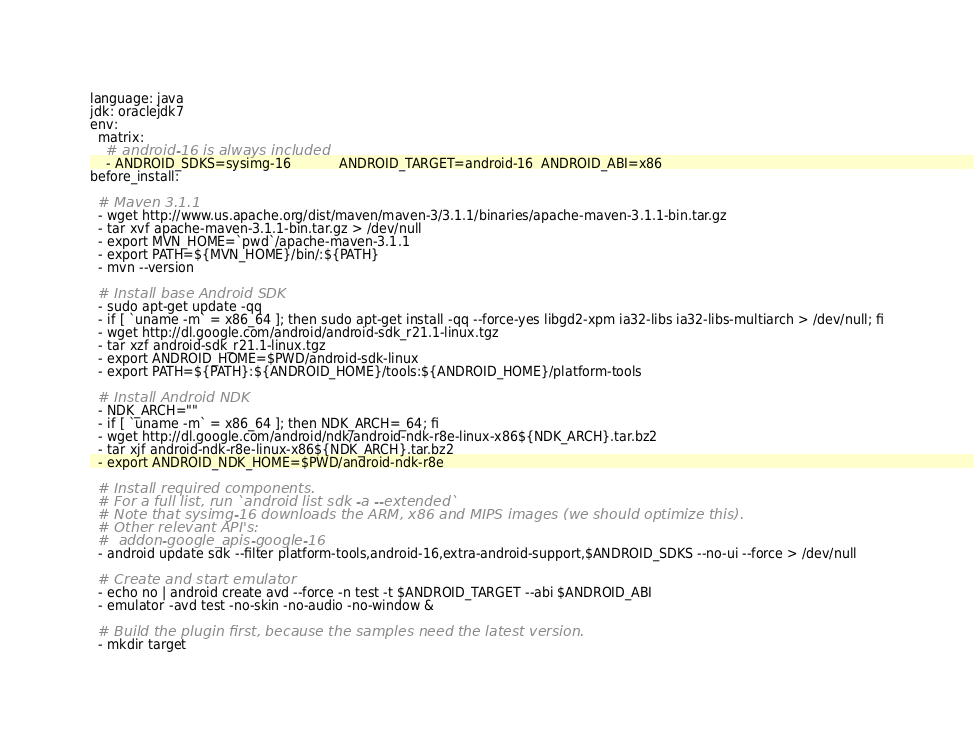<code> <loc_0><loc_0><loc_500><loc_500><_YAML_>language: java
jdk: oraclejdk7
env:
  matrix:
    # android-16 is always included
    - ANDROID_SDKS=sysimg-16            ANDROID_TARGET=android-16  ANDROID_ABI=x86
before_install:

  # Maven 3.1.1
  - wget http://www.us.apache.org/dist/maven/maven-3/3.1.1/binaries/apache-maven-3.1.1-bin.tar.gz
  - tar xvf apache-maven-3.1.1-bin.tar.gz > /dev/null
  - export MVN_HOME=`pwd`/apache-maven-3.1.1
  - export PATH=${MVN_HOME}/bin/:${PATH}
  - mvn --version
  
  # Install base Android SDK
  - sudo apt-get update -qq
  - if [ `uname -m` = x86_64 ]; then sudo apt-get install -qq --force-yes libgd2-xpm ia32-libs ia32-libs-multiarch > /dev/null; fi
  - wget http://dl.google.com/android/android-sdk_r21.1-linux.tgz
  - tar xzf android-sdk_r21.1-linux.tgz
  - export ANDROID_HOME=$PWD/android-sdk-linux
  - export PATH=${PATH}:${ANDROID_HOME}/tools:${ANDROID_HOME}/platform-tools

  # Install Android NDK
  - NDK_ARCH=""
  - if [ `uname -m` = x86_64 ]; then NDK_ARCH=_64; fi
  - wget http://dl.google.com/android/ndk/android-ndk-r8e-linux-x86${NDK_ARCH}.tar.bz2
  - tar xjf android-ndk-r8e-linux-x86${NDK_ARCH}.tar.bz2
  - export ANDROID_NDK_HOME=$PWD/android-ndk-r8e

  # Install required components.
  # For a full list, run `android list sdk -a --extended`
  # Note that sysimg-16 downloads the ARM, x86 and MIPS images (we should optimize this).
  # Other relevant API's:
  #  addon-google_apis-google-16
  - android update sdk --filter platform-tools,android-16,extra-android-support,$ANDROID_SDKS --no-ui --force > /dev/null

  # Create and start emulator
  - echo no | android create avd --force -n test -t $ANDROID_TARGET --abi $ANDROID_ABI
  - emulator -avd test -no-skin -no-audio -no-window &

  # Build the plugin first, because the samples need the latest version.
  - mkdir target</code> 